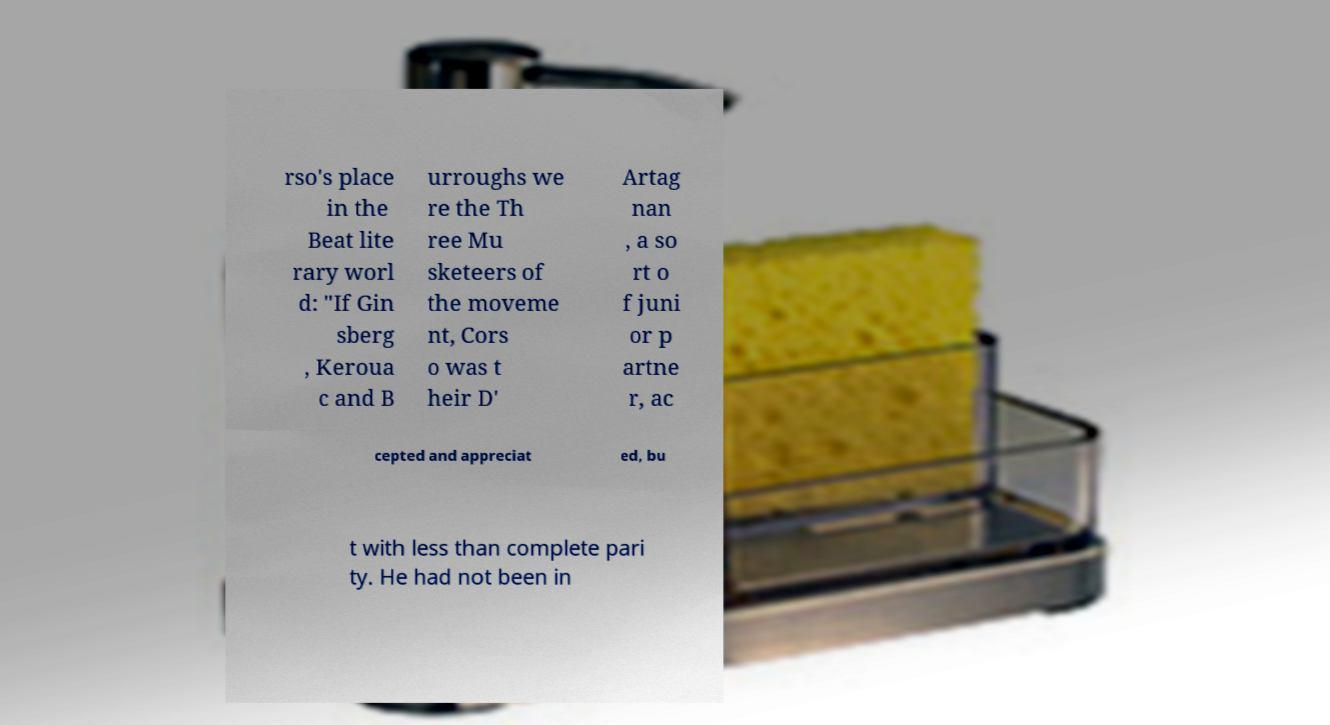Can you read and provide the text displayed in the image?This photo seems to have some interesting text. Can you extract and type it out for me? rso's place in the Beat lite rary worl d: "If Gin sberg , Keroua c and B urroughs we re the Th ree Mu sketeers of the moveme nt, Cors o was t heir D' Artag nan , a so rt o f juni or p artne r, ac cepted and appreciat ed, bu t with less than complete pari ty. He had not been in 